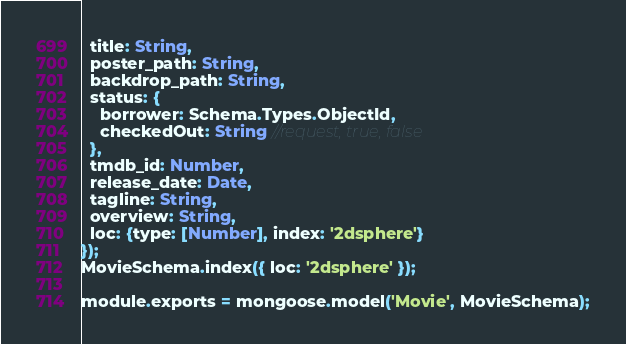Convert code to text. <code><loc_0><loc_0><loc_500><loc_500><_JavaScript_>  title: String,
  poster_path: String,
  backdrop_path: String,
  status: {
    borrower: Schema.Types.ObjectId,
    checkedOut: String //request, true, false
  },
  tmdb_id: Number,
  release_date: Date,
  tagline: String,
  overview: String,
  loc: {type: [Number], index: '2dsphere'}
});
MovieSchema.index({ loc: '2dsphere' });

module.exports = mongoose.model('Movie', MovieSchema);
</code> 